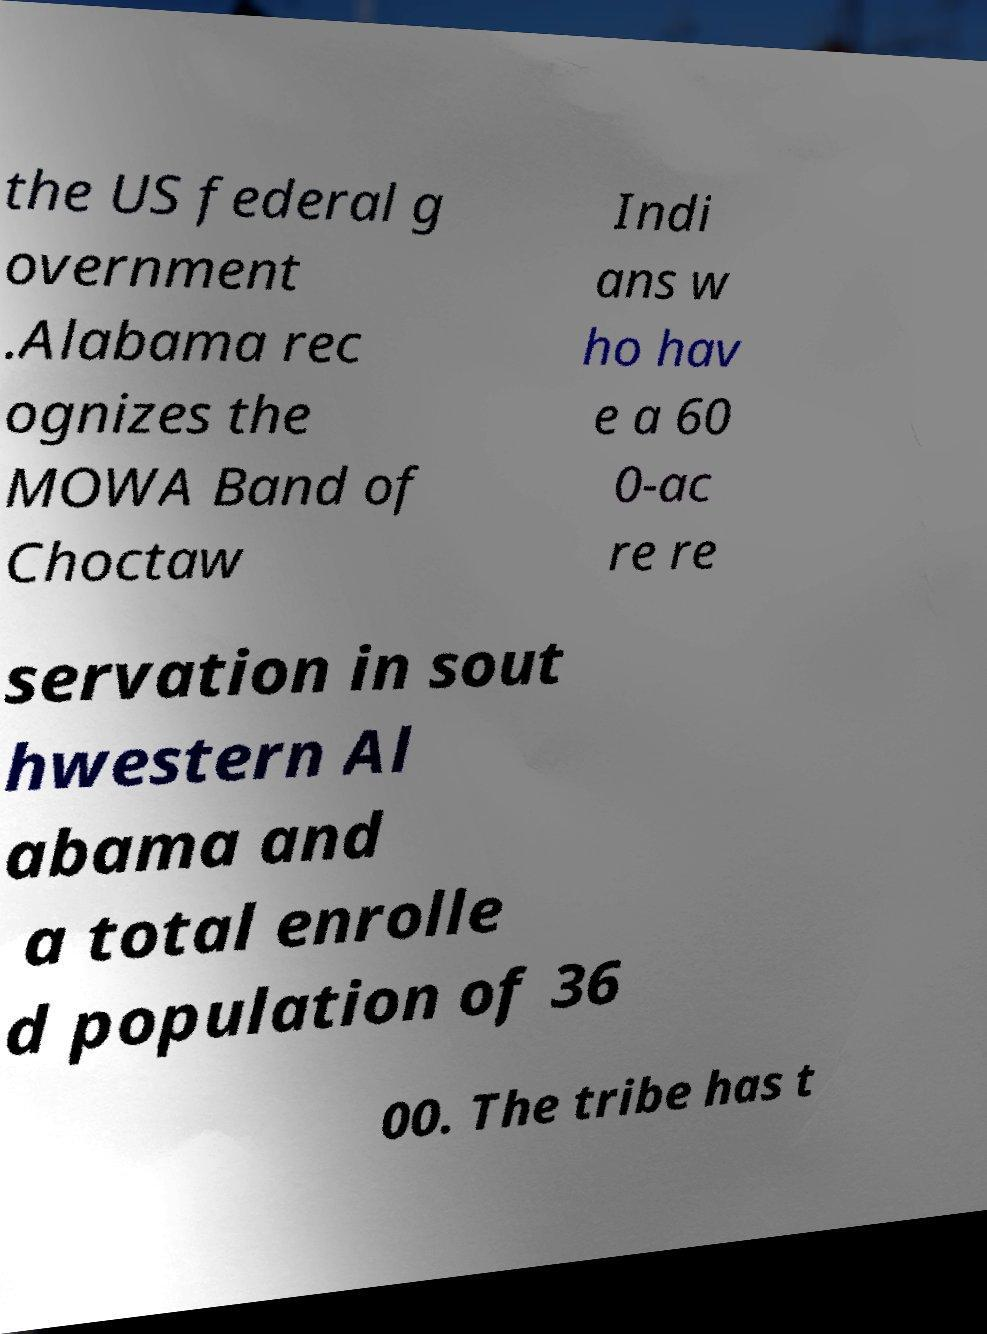Could you extract and type out the text from this image? the US federal g overnment .Alabama rec ognizes the MOWA Band of Choctaw Indi ans w ho hav e a 60 0-ac re re servation in sout hwestern Al abama and a total enrolle d population of 36 00. The tribe has t 